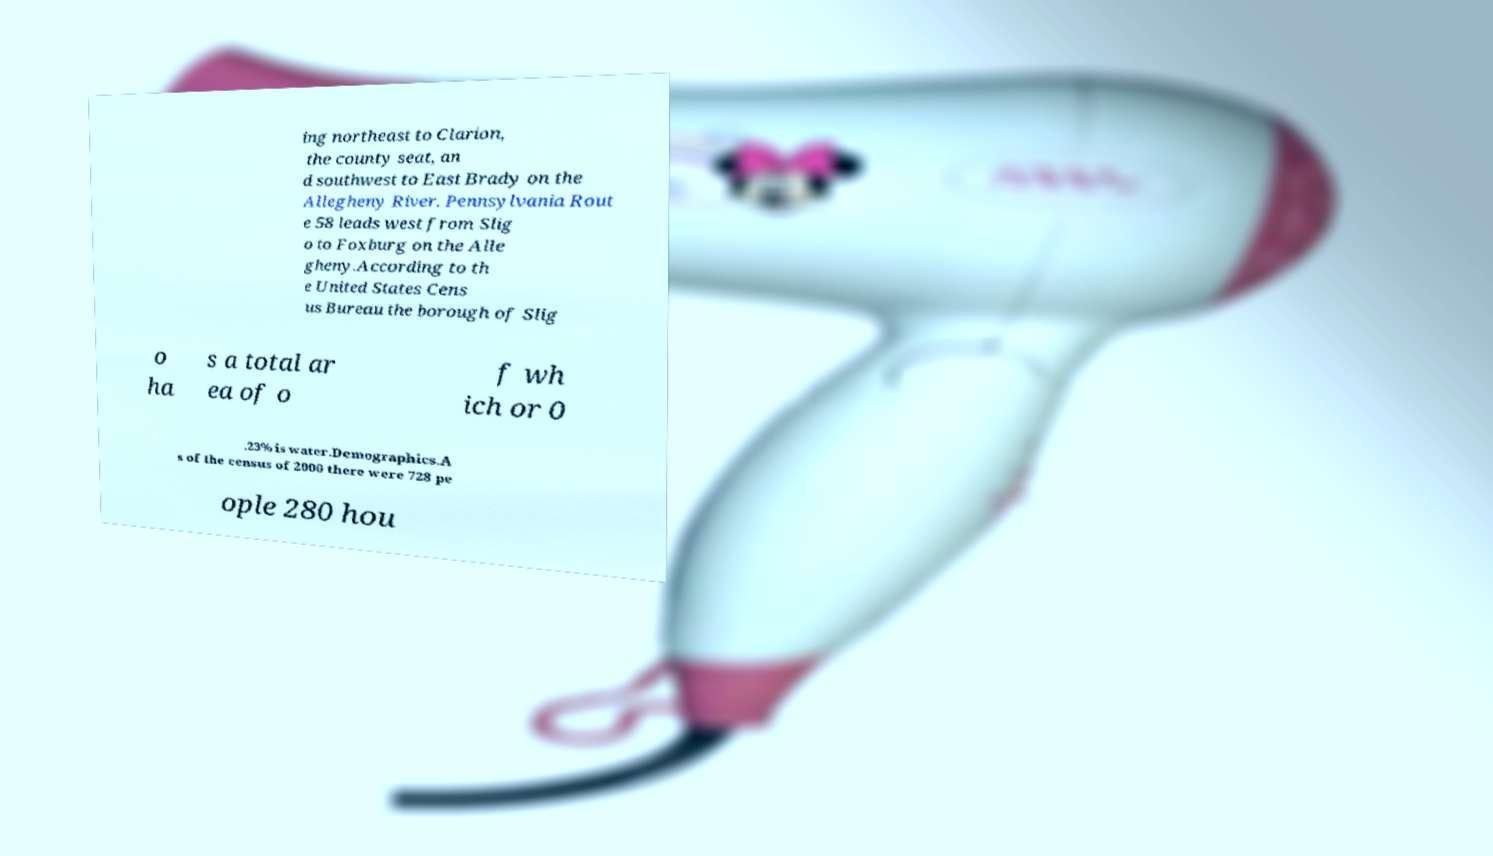There's text embedded in this image that I need extracted. Can you transcribe it verbatim? ing northeast to Clarion, the county seat, an d southwest to East Brady on the Allegheny River. Pennsylvania Rout e 58 leads west from Slig o to Foxburg on the Alle gheny.According to th e United States Cens us Bureau the borough of Slig o ha s a total ar ea of o f wh ich or 0 .23% is water.Demographics.A s of the census of 2000 there were 728 pe ople 280 hou 